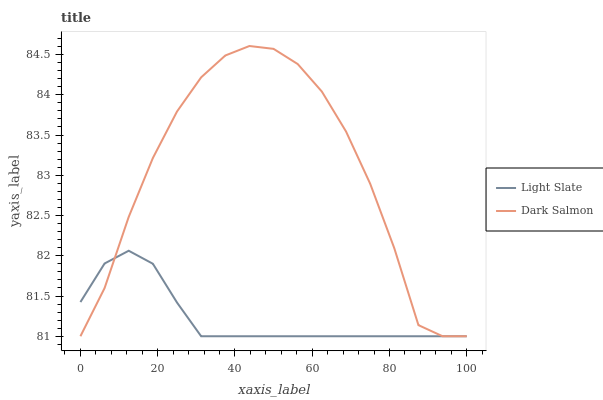Does Light Slate have the minimum area under the curve?
Answer yes or no. Yes. Does Dark Salmon have the maximum area under the curve?
Answer yes or no. Yes. Does Dark Salmon have the minimum area under the curve?
Answer yes or no. No. Is Light Slate the smoothest?
Answer yes or no. Yes. Is Dark Salmon the roughest?
Answer yes or no. Yes. Is Dark Salmon the smoothest?
Answer yes or no. No. Does Light Slate have the lowest value?
Answer yes or no. Yes. Does Dark Salmon have the highest value?
Answer yes or no. Yes. Does Dark Salmon intersect Light Slate?
Answer yes or no. Yes. Is Dark Salmon less than Light Slate?
Answer yes or no. No. Is Dark Salmon greater than Light Slate?
Answer yes or no. No. 